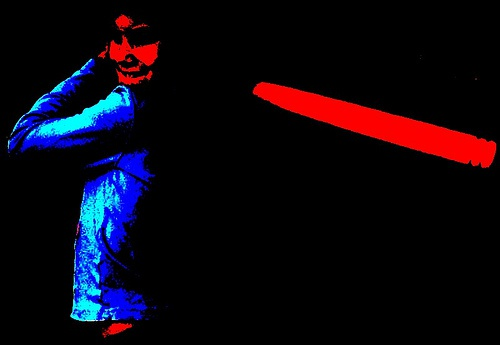Describe the objects in this image and their specific colors. I can see people in black, blue, cyan, and red tones and baseball bat in black, red, brown, and maroon tones in this image. 